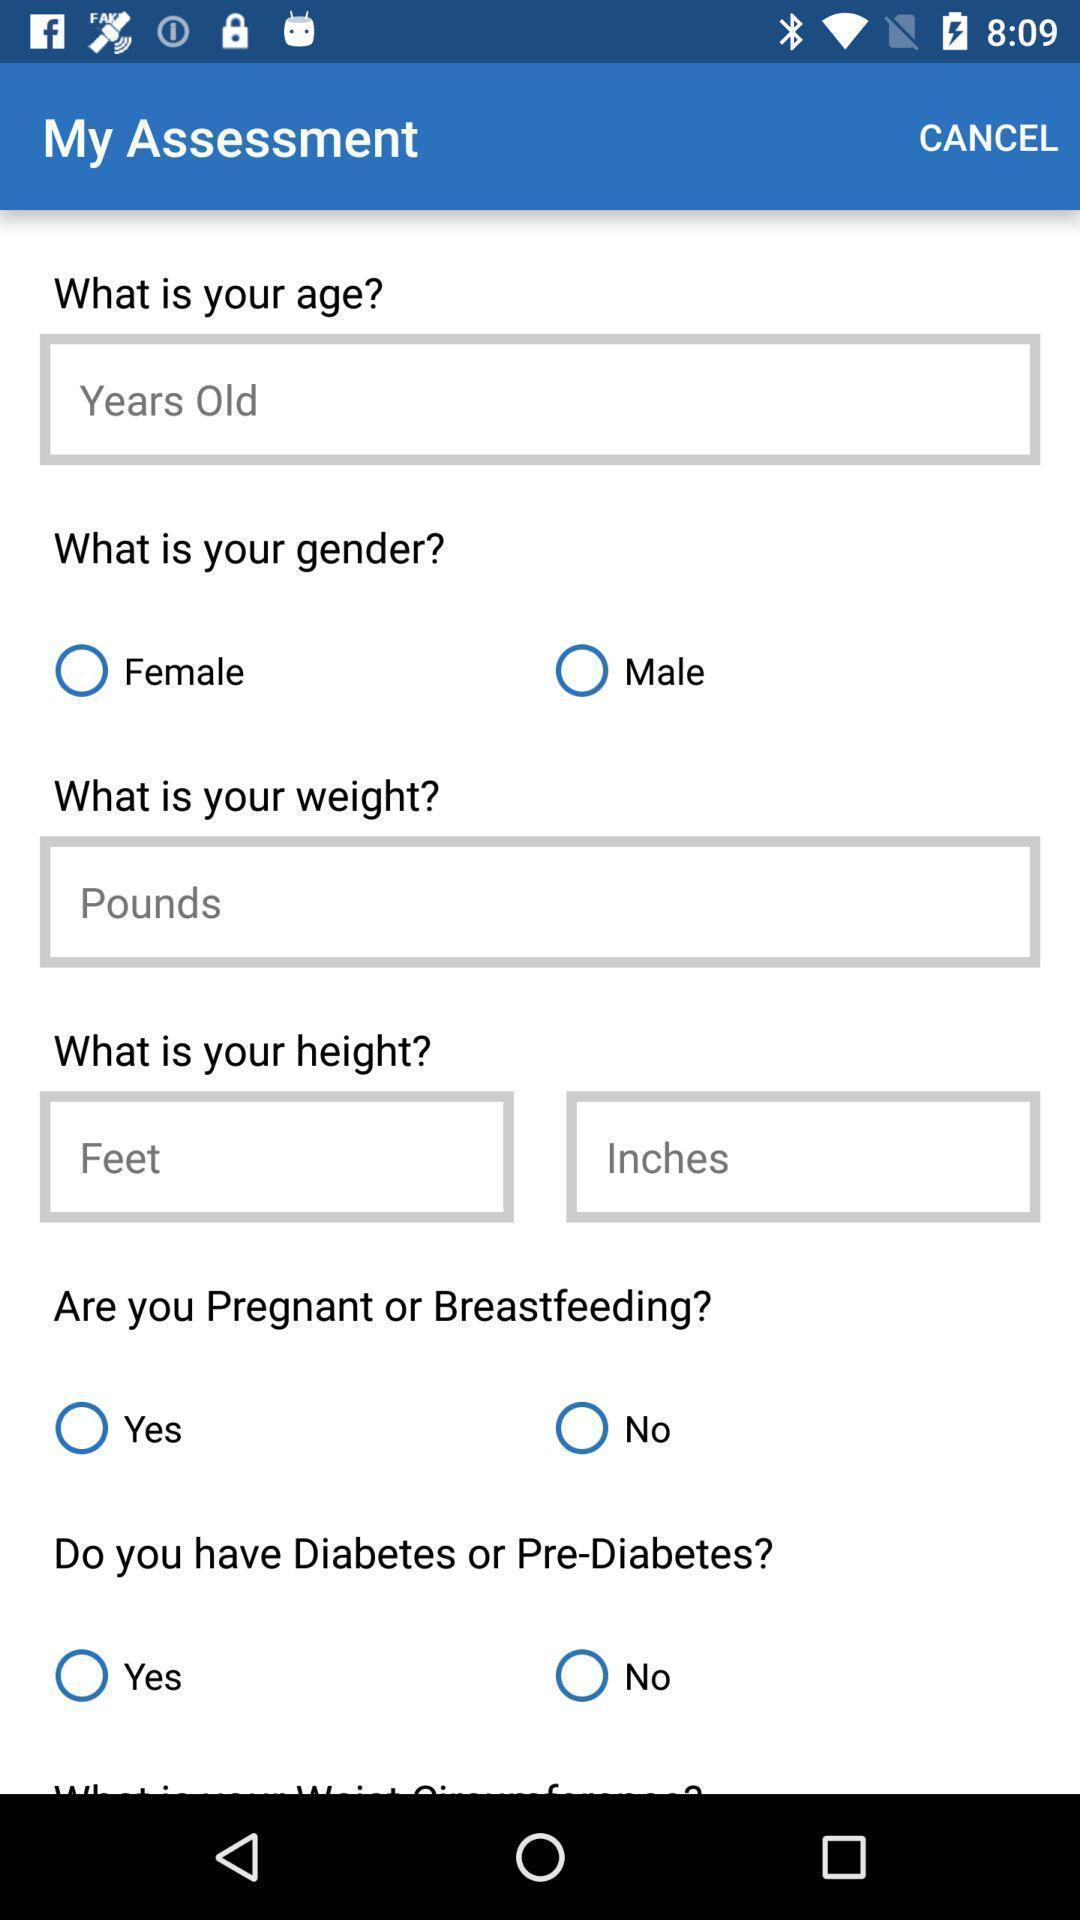Summarize the main components in this picture. Set of questions in a health app. 